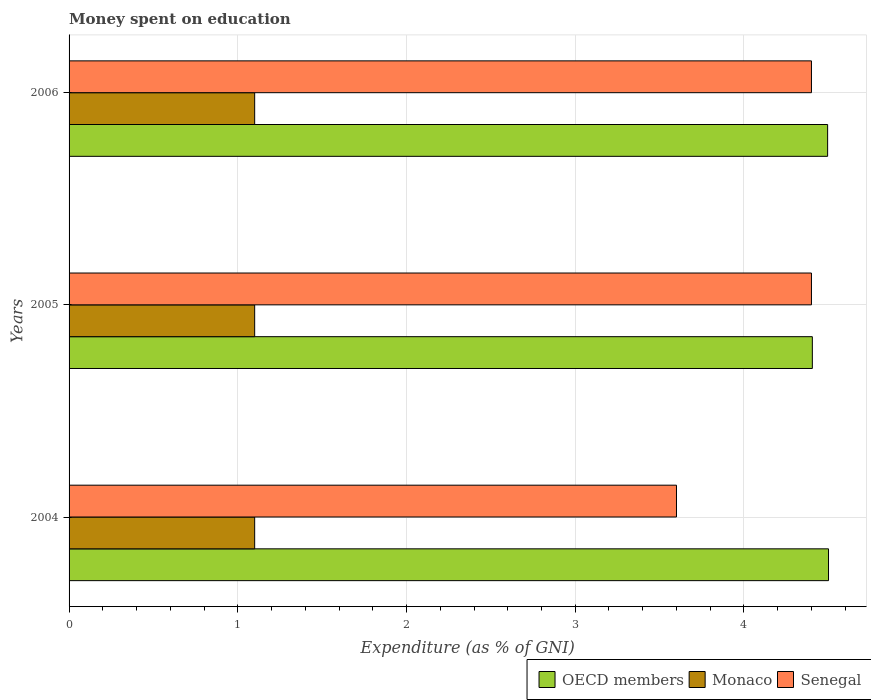How many groups of bars are there?
Provide a short and direct response. 3. Are the number of bars per tick equal to the number of legend labels?
Your response must be concise. Yes. What is the label of the 1st group of bars from the top?
Make the answer very short. 2006. In how many cases, is the number of bars for a given year not equal to the number of legend labels?
Your response must be concise. 0. What is the amount of money spent on education in Senegal in 2004?
Offer a very short reply. 3.6. Across all years, what is the minimum amount of money spent on education in OECD members?
Provide a succinct answer. 4.41. In which year was the amount of money spent on education in Monaco maximum?
Ensure brevity in your answer.  2004. In which year was the amount of money spent on education in OECD members minimum?
Make the answer very short. 2005. What is the total amount of money spent on education in OECD members in the graph?
Your response must be concise. 13.4. What is the difference between the amount of money spent on education in Monaco in 2004 and that in 2005?
Provide a short and direct response. 0. What is the difference between the amount of money spent on education in Monaco in 2006 and the amount of money spent on education in OECD members in 2005?
Offer a terse response. -3.31. What is the average amount of money spent on education in Senegal per year?
Offer a terse response. 4.13. In the year 2004, what is the difference between the amount of money spent on education in OECD members and amount of money spent on education in Monaco?
Make the answer very short. 3.4. In how many years, is the amount of money spent on education in OECD members greater than 3.2 %?
Offer a very short reply. 3. What is the ratio of the amount of money spent on education in Senegal in 2005 to that in 2006?
Provide a short and direct response. 1. Is the difference between the amount of money spent on education in OECD members in 2005 and 2006 greater than the difference between the amount of money spent on education in Monaco in 2005 and 2006?
Make the answer very short. No. What is the difference between the highest and the second highest amount of money spent on education in OECD members?
Your answer should be very brief. 0.01. What is the difference between the highest and the lowest amount of money spent on education in Monaco?
Your response must be concise. 0. In how many years, is the amount of money spent on education in OECD members greater than the average amount of money spent on education in OECD members taken over all years?
Keep it short and to the point. 2. Is the sum of the amount of money spent on education in Monaco in 2005 and 2006 greater than the maximum amount of money spent on education in OECD members across all years?
Give a very brief answer. No. What does the 1st bar from the top in 2004 represents?
Offer a very short reply. Senegal. What does the 3rd bar from the bottom in 2004 represents?
Your response must be concise. Senegal. Is it the case that in every year, the sum of the amount of money spent on education in Monaco and amount of money spent on education in OECD members is greater than the amount of money spent on education in Senegal?
Your answer should be compact. Yes. How many bars are there?
Your answer should be very brief. 9. Are all the bars in the graph horizontal?
Provide a succinct answer. Yes. How many years are there in the graph?
Give a very brief answer. 3. What is the difference between two consecutive major ticks on the X-axis?
Provide a succinct answer. 1. Are the values on the major ticks of X-axis written in scientific E-notation?
Your answer should be very brief. No. Does the graph contain any zero values?
Your answer should be compact. No. How many legend labels are there?
Offer a very short reply. 3. What is the title of the graph?
Offer a terse response. Money spent on education. What is the label or title of the X-axis?
Your response must be concise. Expenditure (as % of GNI). What is the label or title of the Y-axis?
Offer a terse response. Years. What is the Expenditure (as % of GNI) in OECD members in 2004?
Provide a short and direct response. 4.5. What is the Expenditure (as % of GNI) of OECD members in 2005?
Your answer should be very brief. 4.41. What is the Expenditure (as % of GNI) in Monaco in 2005?
Provide a short and direct response. 1.1. What is the Expenditure (as % of GNI) in Senegal in 2005?
Give a very brief answer. 4.4. What is the Expenditure (as % of GNI) of OECD members in 2006?
Ensure brevity in your answer.  4.5. Across all years, what is the maximum Expenditure (as % of GNI) in OECD members?
Your response must be concise. 4.5. Across all years, what is the maximum Expenditure (as % of GNI) in Monaco?
Ensure brevity in your answer.  1.1. Across all years, what is the minimum Expenditure (as % of GNI) in OECD members?
Offer a terse response. 4.41. Across all years, what is the minimum Expenditure (as % of GNI) of Monaco?
Keep it short and to the point. 1.1. Across all years, what is the minimum Expenditure (as % of GNI) in Senegal?
Ensure brevity in your answer.  3.6. What is the total Expenditure (as % of GNI) in OECD members in the graph?
Ensure brevity in your answer.  13.4. What is the total Expenditure (as % of GNI) in Senegal in the graph?
Offer a very short reply. 12.4. What is the difference between the Expenditure (as % of GNI) of OECD members in 2004 and that in 2005?
Your answer should be compact. 0.1. What is the difference between the Expenditure (as % of GNI) of OECD members in 2004 and that in 2006?
Ensure brevity in your answer.  0.01. What is the difference between the Expenditure (as % of GNI) of Monaco in 2004 and that in 2006?
Offer a very short reply. 0. What is the difference between the Expenditure (as % of GNI) in OECD members in 2005 and that in 2006?
Give a very brief answer. -0.09. What is the difference between the Expenditure (as % of GNI) of Monaco in 2005 and that in 2006?
Provide a succinct answer. 0. What is the difference between the Expenditure (as % of GNI) in Senegal in 2005 and that in 2006?
Provide a short and direct response. 0. What is the difference between the Expenditure (as % of GNI) in OECD members in 2004 and the Expenditure (as % of GNI) in Monaco in 2005?
Provide a short and direct response. 3.4. What is the difference between the Expenditure (as % of GNI) of OECD members in 2004 and the Expenditure (as % of GNI) of Senegal in 2005?
Your response must be concise. 0.1. What is the difference between the Expenditure (as % of GNI) of Monaco in 2004 and the Expenditure (as % of GNI) of Senegal in 2005?
Your response must be concise. -3.3. What is the difference between the Expenditure (as % of GNI) of OECD members in 2004 and the Expenditure (as % of GNI) of Monaco in 2006?
Provide a short and direct response. 3.4. What is the difference between the Expenditure (as % of GNI) in OECD members in 2004 and the Expenditure (as % of GNI) in Senegal in 2006?
Your answer should be very brief. 0.1. What is the difference between the Expenditure (as % of GNI) in Monaco in 2004 and the Expenditure (as % of GNI) in Senegal in 2006?
Your answer should be very brief. -3.3. What is the difference between the Expenditure (as % of GNI) of OECD members in 2005 and the Expenditure (as % of GNI) of Monaco in 2006?
Make the answer very short. 3.31. What is the difference between the Expenditure (as % of GNI) in OECD members in 2005 and the Expenditure (as % of GNI) in Senegal in 2006?
Offer a terse response. 0.01. What is the difference between the Expenditure (as % of GNI) of Monaco in 2005 and the Expenditure (as % of GNI) of Senegal in 2006?
Offer a very short reply. -3.3. What is the average Expenditure (as % of GNI) in OECD members per year?
Offer a terse response. 4.47. What is the average Expenditure (as % of GNI) of Monaco per year?
Your answer should be very brief. 1.1. What is the average Expenditure (as % of GNI) of Senegal per year?
Your response must be concise. 4.13. In the year 2004, what is the difference between the Expenditure (as % of GNI) of OECD members and Expenditure (as % of GNI) of Monaco?
Your answer should be very brief. 3.4. In the year 2004, what is the difference between the Expenditure (as % of GNI) in OECD members and Expenditure (as % of GNI) in Senegal?
Give a very brief answer. 0.9. In the year 2005, what is the difference between the Expenditure (as % of GNI) of OECD members and Expenditure (as % of GNI) of Monaco?
Make the answer very short. 3.31. In the year 2005, what is the difference between the Expenditure (as % of GNI) in OECD members and Expenditure (as % of GNI) in Senegal?
Offer a very short reply. 0.01. In the year 2005, what is the difference between the Expenditure (as % of GNI) in Monaco and Expenditure (as % of GNI) in Senegal?
Provide a short and direct response. -3.3. In the year 2006, what is the difference between the Expenditure (as % of GNI) in OECD members and Expenditure (as % of GNI) in Monaco?
Your response must be concise. 3.4. In the year 2006, what is the difference between the Expenditure (as % of GNI) of OECD members and Expenditure (as % of GNI) of Senegal?
Ensure brevity in your answer.  0.1. What is the ratio of the Expenditure (as % of GNI) in OECD members in 2004 to that in 2005?
Make the answer very short. 1.02. What is the ratio of the Expenditure (as % of GNI) of Senegal in 2004 to that in 2005?
Offer a terse response. 0.82. What is the ratio of the Expenditure (as % of GNI) in OECD members in 2004 to that in 2006?
Your answer should be very brief. 1. What is the ratio of the Expenditure (as % of GNI) of Monaco in 2004 to that in 2006?
Give a very brief answer. 1. What is the ratio of the Expenditure (as % of GNI) in Senegal in 2004 to that in 2006?
Make the answer very short. 0.82. What is the ratio of the Expenditure (as % of GNI) in OECD members in 2005 to that in 2006?
Make the answer very short. 0.98. What is the ratio of the Expenditure (as % of GNI) in Monaco in 2005 to that in 2006?
Give a very brief answer. 1. What is the difference between the highest and the second highest Expenditure (as % of GNI) in OECD members?
Make the answer very short. 0.01. What is the difference between the highest and the second highest Expenditure (as % of GNI) in Monaco?
Ensure brevity in your answer.  0. What is the difference between the highest and the second highest Expenditure (as % of GNI) in Senegal?
Give a very brief answer. 0. What is the difference between the highest and the lowest Expenditure (as % of GNI) in OECD members?
Keep it short and to the point. 0.1. 